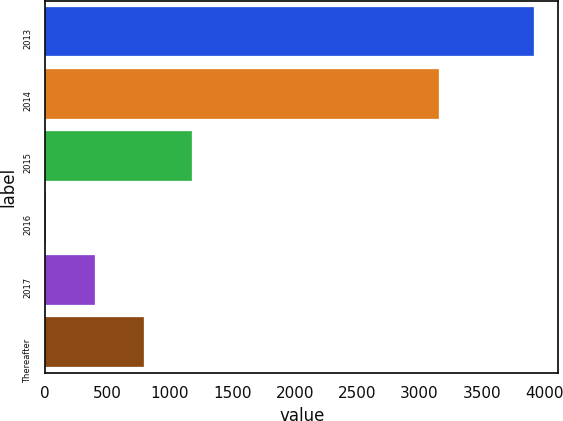<chart> <loc_0><loc_0><loc_500><loc_500><bar_chart><fcel>2013<fcel>2014<fcel>2015<fcel>2016<fcel>2017<fcel>Thereafter<nl><fcel>3917<fcel>3155<fcel>1180<fcel>7<fcel>398<fcel>789<nl></chart> 